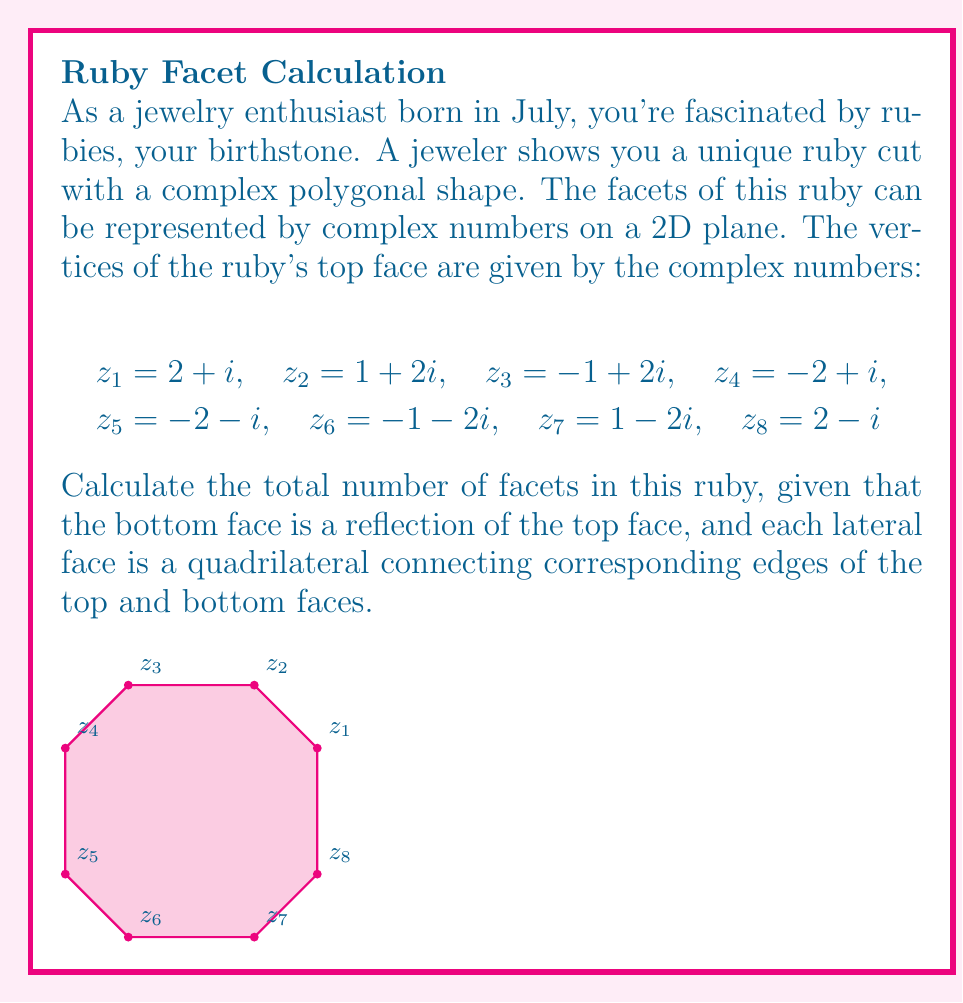Help me with this question. Let's approach this step-by-step:

1) First, we need to count the number of faces:
   - Top face: 1
   - Bottom face: 1
   - Lateral faces: We need to determine this

2) To find the number of lateral faces, we need to count the edges of the top (or bottom) face:
   - The top face is an octagon (8-sided polygon)
   - Each edge of the top face corresponds to one lateral face

3) Counting the lateral faces:
   - Number of lateral faces = Number of edges in the top face = 8

4) Now we can sum up all the faces:
   - Total faces = Top face + Bottom face + Lateral faces
   - Total faces = 1 + 1 + 8 = 10

5) Therefore, the ruby has 10 facets in total.

Note: In this problem, the complex number representation helps us visualize the shape of the ruby's top face. Each complex number $z_k = a + bi$ represents a point $(a,b)$ on the complex plane, which corresponds to a vertex of the octagonal top face of the ruby.
Answer: 10 facets 